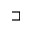<formula> <loc_0><loc_0><loc_500><loc_500>\sqsupset</formula> 